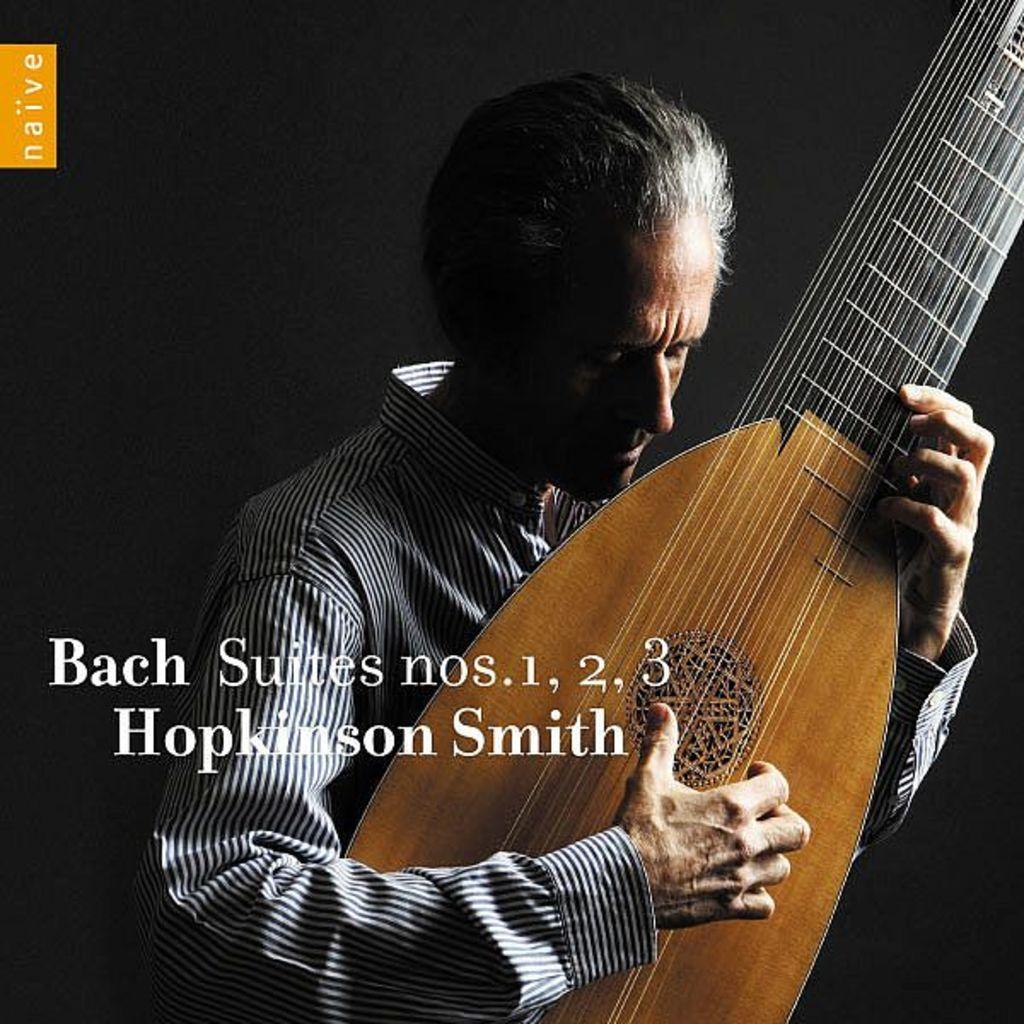Can you describe this image briefly? In this picture, we see a man in black and white shirt is holding a guitar in his hands and is playing it. In the middle of the picture, we see some text written on it. 